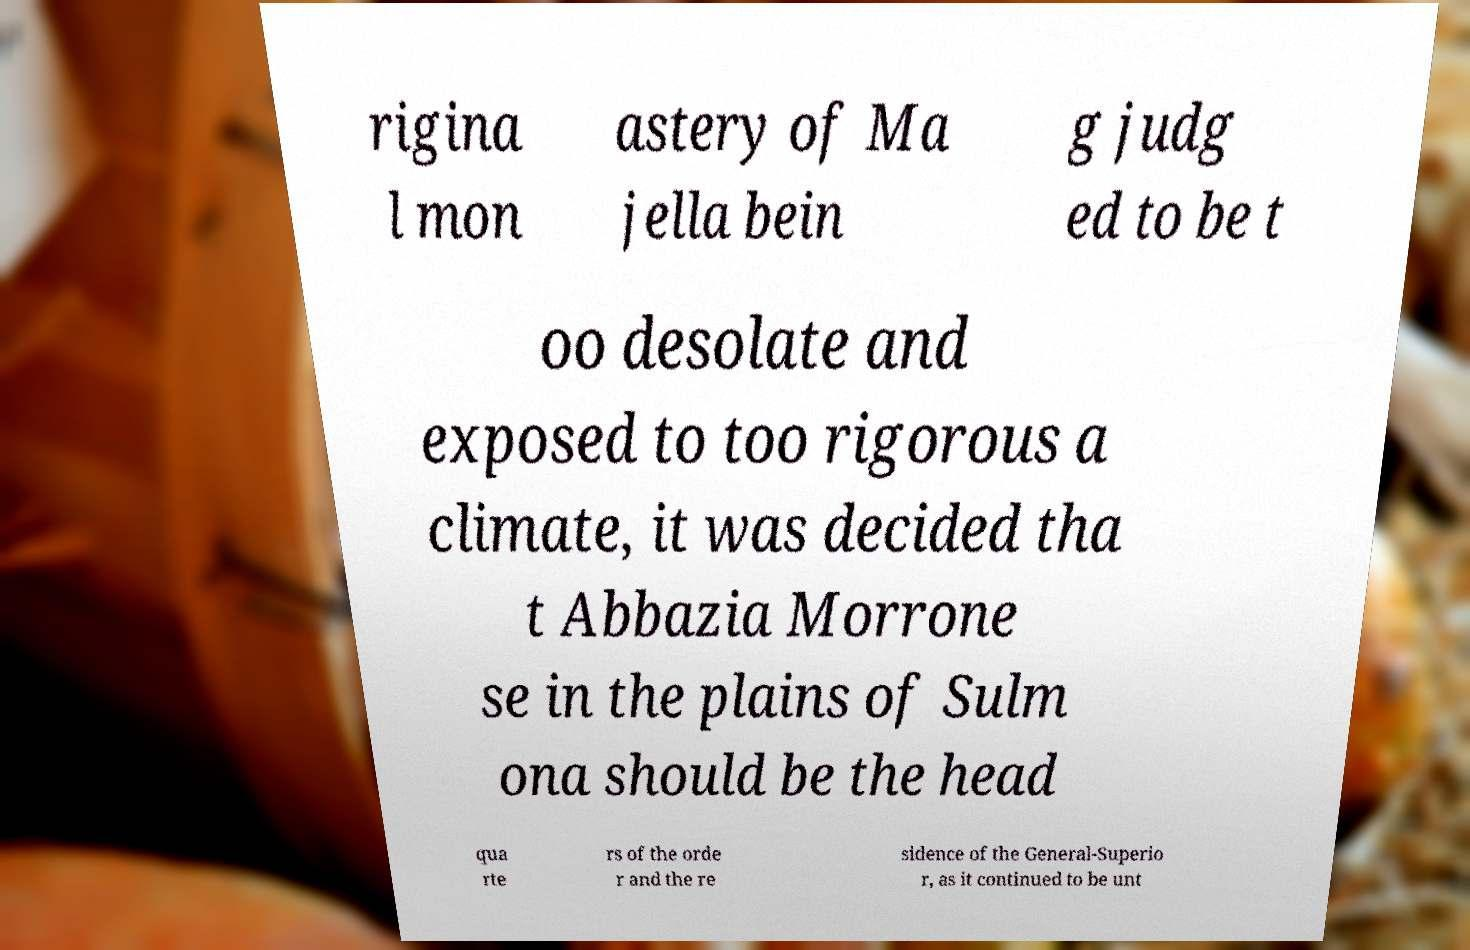Could you assist in decoding the text presented in this image and type it out clearly? rigina l mon astery of Ma jella bein g judg ed to be t oo desolate and exposed to too rigorous a climate, it was decided tha t Abbazia Morrone se in the plains of Sulm ona should be the head qua rte rs of the orde r and the re sidence of the General-Superio r, as it continued to be unt 